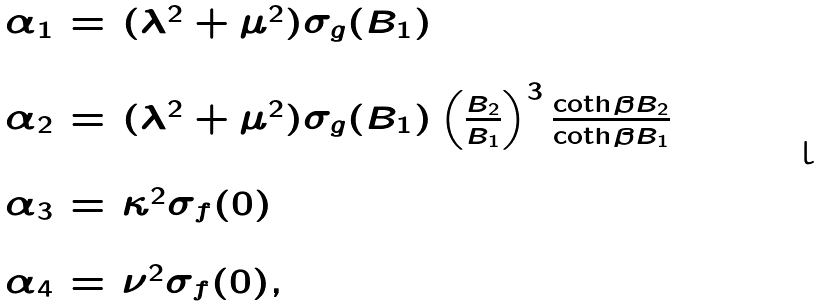<formula> <loc_0><loc_0><loc_500><loc_500>\begin{array} { l l l } \alpha _ { 1 } & = & ( \lambda ^ { 2 } + \mu ^ { 2 } ) \sigma _ { g } ( B _ { 1 } ) \\ & & \\ \alpha _ { 2 } & = & ( \lambda ^ { 2 } + \mu ^ { 2 } ) \sigma _ { g } ( B _ { 1 } ) \left ( \frac { B _ { 2 } } { B _ { 1 } } \right ) ^ { 3 } \frac { \coth \beta B _ { 2 } } { \coth \beta B _ { 1 } } \\ & & \\ \alpha _ { 3 } & = & \kappa ^ { 2 } \sigma _ { f } ( 0 ) \\ & & \\ \alpha _ { 4 } & = & \nu ^ { 2 } \sigma _ { f } ( 0 ) , \end{array}</formula> 